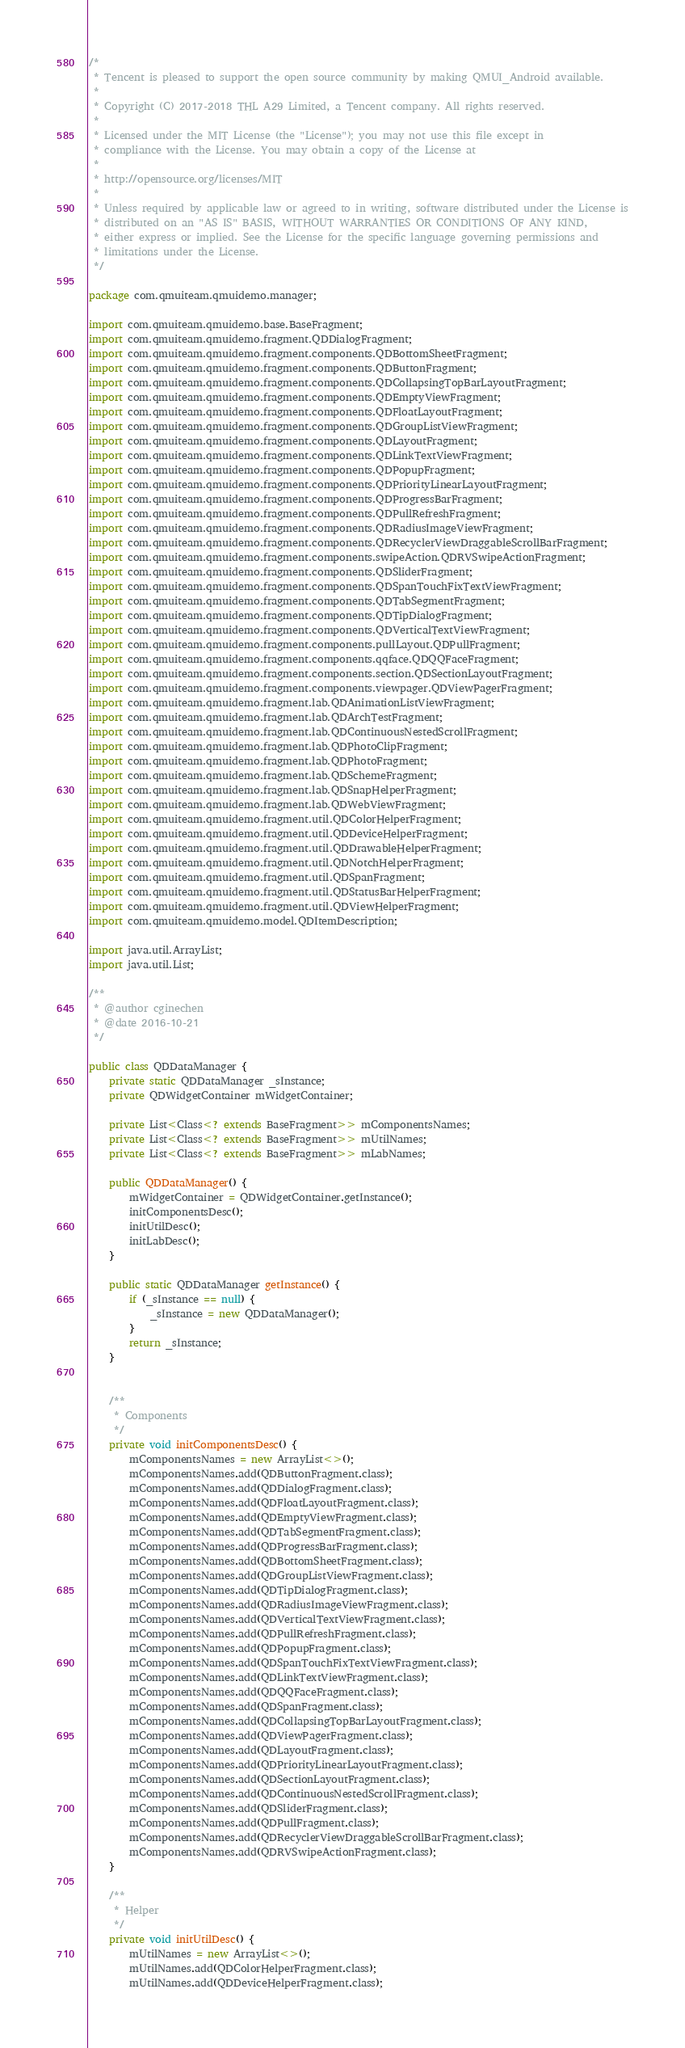<code> <loc_0><loc_0><loc_500><loc_500><_Java_>/*
 * Tencent is pleased to support the open source community by making QMUI_Android available.
 *
 * Copyright (C) 2017-2018 THL A29 Limited, a Tencent company. All rights reserved.
 *
 * Licensed under the MIT License (the "License"); you may not use this file except in
 * compliance with the License. You may obtain a copy of the License at
 *
 * http://opensource.org/licenses/MIT
 *
 * Unless required by applicable law or agreed to in writing, software distributed under the License is
 * distributed on an "AS IS" BASIS, WITHOUT WARRANTIES OR CONDITIONS OF ANY KIND,
 * either express or implied. See the License for the specific language governing permissions and
 * limitations under the License.
 */

package com.qmuiteam.qmuidemo.manager;

import com.qmuiteam.qmuidemo.base.BaseFragment;
import com.qmuiteam.qmuidemo.fragment.QDDialogFragment;
import com.qmuiteam.qmuidemo.fragment.components.QDBottomSheetFragment;
import com.qmuiteam.qmuidemo.fragment.components.QDButtonFragment;
import com.qmuiteam.qmuidemo.fragment.components.QDCollapsingTopBarLayoutFragment;
import com.qmuiteam.qmuidemo.fragment.components.QDEmptyViewFragment;
import com.qmuiteam.qmuidemo.fragment.components.QDFloatLayoutFragment;
import com.qmuiteam.qmuidemo.fragment.components.QDGroupListViewFragment;
import com.qmuiteam.qmuidemo.fragment.components.QDLayoutFragment;
import com.qmuiteam.qmuidemo.fragment.components.QDLinkTextViewFragment;
import com.qmuiteam.qmuidemo.fragment.components.QDPopupFragment;
import com.qmuiteam.qmuidemo.fragment.components.QDPriorityLinearLayoutFragment;
import com.qmuiteam.qmuidemo.fragment.components.QDProgressBarFragment;
import com.qmuiteam.qmuidemo.fragment.components.QDPullRefreshFragment;
import com.qmuiteam.qmuidemo.fragment.components.QDRadiusImageViewFragment;
import com.qmuiteam.qmuidemo.fragment.components.QDRecyclerViewDraggableScrollBarFragment;
import com.qmuiteam.qmuidemo.fragment.components.swipeAction.QDRVSwipeActionFragment;
import com.qmuiteam.qmuidemo.fragment.components.QDSliderFragment;
import com.qmuiteam.qmuidemo.fragment.components.QDSpanTouchFixTextViewFragment;
import com.qmuiteam.qmuidemo.fragment.components.QDTabSegmentFragment;
import com.qmuiteam.qmuidemo.fragment.components.QDTipDialogFragment;
import com.qmuiteam.qmuidemo.fragment.components.QDVerticalTextViewFragment;
import com.qmuiteam.qmuidemo.fragment.components.pullLayout.QDPullFragment;
import com.qmuiteam.qmuidemo.fragment.components.qqface.QDQQFaceFragment;
import com.qmuiteam.qmuidemo.fragment.components.section.QDSectionLayoutFragment;
import com.qmuiteam.qmuidemo.fragment.components.viewpager.QDViewPagerFragment;
import com.qmuiteam.qmuidemo.fragment.lab.QDAnimationListViewFragment;
import com.qmuiteam.qmuidemo.fragment.lab.QDArchTestFragment;
import com.qmuiteam.qmuidemo.fragment.lab.QDContinuousNestedScrollFragment;
import com.qmuiteam.qmuidemo.fragment.lab.QDPhotoClipFragment;
import com.qmuiteam.qmuidemo.fragment.lab.QDPhotoFragment;
import com.qmuiteam.qmuidemo.fragment.lab.QDSchemeFragment;
import com.qmuiteam.qmuidemo.fragment.lab.QDSnapHelperFragment;
import com.qmuiteam.qmuidemo.fragment.lab.QDWebViewFragment;
import com.qmuiteam.qmuidemo.fragment.util.QDColorHelperFragment;
import com.qmuiteam.qmuidemo.fragment.util.QDDeviceHelperFragment;
import com.qmuiteam.qmuidemo.fragment.util.QDDrawableHelperFragment;
import com.qmuiteam.qmuidemo.fragment.util.QDNotchHelperFragment;
import com.qmuiteam.qmuidemo.fragment.util.QDSpanFragment;
import com.qmuiteam.qmuidemo.fragment.util.QDStatusBarHelperFragment;
import com.qmuiteam.qmuidemo.fragment.util.QDViewHelperFragment;
import com.qmuiteam.qmuidemo.model.QDItemDescription;

import java.util.ArrayList;
import java.util.List;

/**
 * @author cginechen
 * @date 2016-10-21
 */

public class QDDataManager {
    private static QDDataManager _sInstance;
    private QDWidgetContainer mWidgetContainer;

    private List<Class<? extends BaseFragment>> mComponentsNames;
    private List<Class<? extends BaseFragment>> mUtilNames;
    private List<Class<? extends BaseFragment>> mLabNames;

    public QDDataManager() {
        mWidgetContainer = QDWidgetContainer.getInstance();
        initComponentsDesc();
        initUtilDesc();
        initLabDesc();
    }

    public static QDDataManager getInstance() {
        if (_sInstance == null) {
            _sInstance = new QDDataManager();
        }
        return _sInstance;
    }


    /**
     * Components
     */
    private void initComponentsDesc() {
        mComponentsNames = new ArrayList<>();
        mComponentsNames.add(QDButtonFragment.class);
        mComponentsNames.add(QDDialogFragment.class);
        mComponentsNames.add(QDFloatLayoutFragment.class);
        mComponentsNames.add(QDEmptyViewFragment.class);
        mComponentsNames.add(QDTabSegmentFragment.class);
        mComponentsNames.add(QDProgressBarFragment.class);
        mComponentsNames.add(QDBottomSheetFragment.class);
        mComponentsNames.add(QDGroupListViewFragment.class);
        mComponentsNames.add(QDTipDialogFragment.class);
        mComponentsNames.add(QDRadiusImageViewFragment.class);
        mComponentsNames.add(QDVerticalTextViewFragment.class);
        mComponentsNames.add(QDPullRefreshFragment.class);
        mComponentsNames.add(QDPopupFragment.class);
        mComponentsNames.add(QDSpanTouchFixTextViewFragment.class);
        mComponentsNames.add(QDLinkTextViewFragment.class);
        mComponentsNames.add(QDQQFaceFragment.class);
        mComponentsNames.add(QDSpanFragment.class);
        mComponentsNames.add(QDCollapsingTopBarLayoutFragment.class);
        mComponentsNames.add(QDViewPagerFragment.class);
        mComponentsNames.add(QDLayoutFragment.class);
        mComponentsNames.add(QDPriorityLinearLayoutFragment.class);
        mComponentsNames.add(QDSectionLayoutFragment.class);
        mComponentsNames.add(QDContinuousNestedScrollFragment.class);
        mComponentsNames.add(QDSliderFragment.class);
        mComponentsNames.add(QDPullFragment.class);
        mComponentsNames.add(QDRecyclerViewDraggableScrollBarFragment.class);
        mComponentsNames.add(QDRVSwipeActionFragment.class);
    }

    /**
     * Helper
     */
    private void initUtilDesc() {
        mUtilNames = new ArrayList<>();
        mUtilNames.add(QDColorHelperFragment.class);
        mUtilNames.add(QDDeviceHelperFragment.class);</code> 